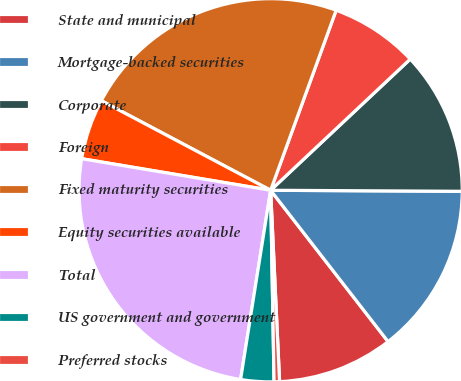<chart> <loc_0><loc_0><loc_500><loc_500><pie_chart><fcel>State and municipal<fcel>Mortgage-backed securities<fcel>Corporate<fcel>Foreign<fcel>Fixed maturity securities<fcel>Equity securities available<fcel>Total<fcel>US government and government<fcel>Preferred stocks<nl><fcel>9.76%<fcel>14.41%<fcel>12.09%<fcel>7.44%<fcel>22.81%<fcel>5.11%<fcel>25.13%<fcel>2.79%<fcel>0.46%<nl></chart> 